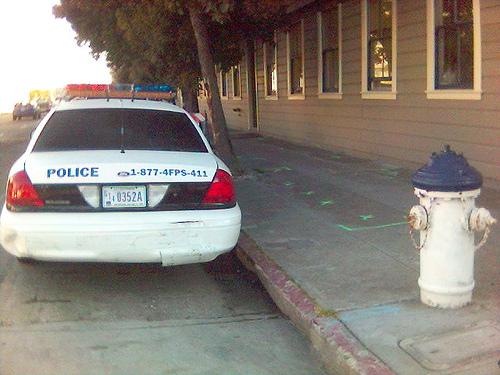What is the number on the car?
Concise answer only. 1-877-4fps-411. What colors are on top of the police car?
Quick response, please. Red and blue. Are there any police officers in the street?
Quick response, please. No. What state police is this?
Give a very brief answer. Connecticut. 